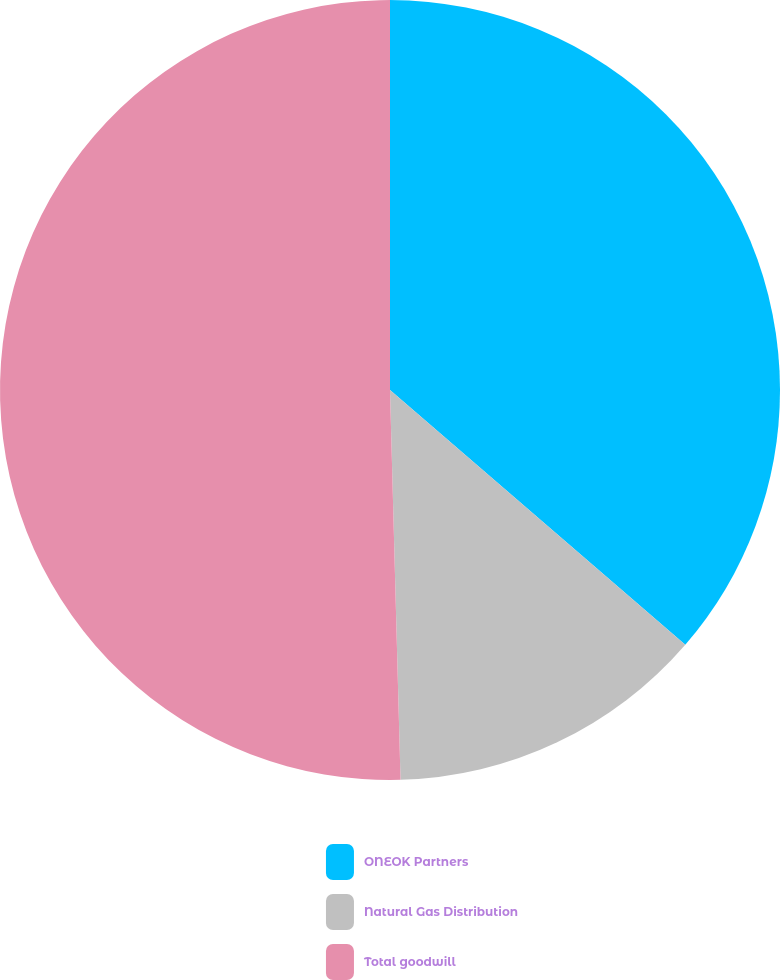<chart> <loc_0><loc_0><loc_500><loc_500><pie_chart><fcel>ONEOK Partners<fcel>Natural Gas Distribution<fcel>Total goodwill<nl><fcel>36.33%<fcel>13.24%<fcel>50.43%<nl></chart> 